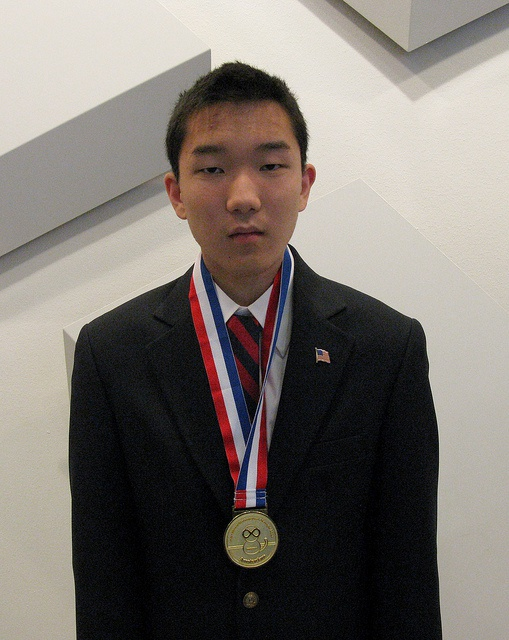Describe the objects in this image and their specific colors. I can see people in lightgray, black, brown, gray, and maroon tones and tie in lightgray, black, maroon, and gray tones in this image. 